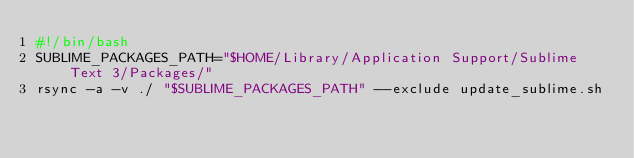<code> <loc_0><loc_0><loc_500><loc_500><_Bash_>#!/bin/bash
SUBLIME_PACKAGES_PATH="$HOME/Library/Application Support/Sublime Text 3/Packages/"
rsync -a -v ./ "$SUBLIME_PACKAGES_PATH" --exclude update_sublime.sh
</code> 